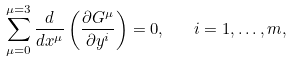<formula> <loc_0><loc_0><loc_500><loc_500>\sum _ { \mu = 0 } ^ { \mu = 3 } \frac { d } { d x ^ { \mu } } \left ( \frac { \partial G ^ { \mu } } { \partial y ^ { i } } \right ) = 0 , \quad i = 1 , \dots , m ,</formula> 